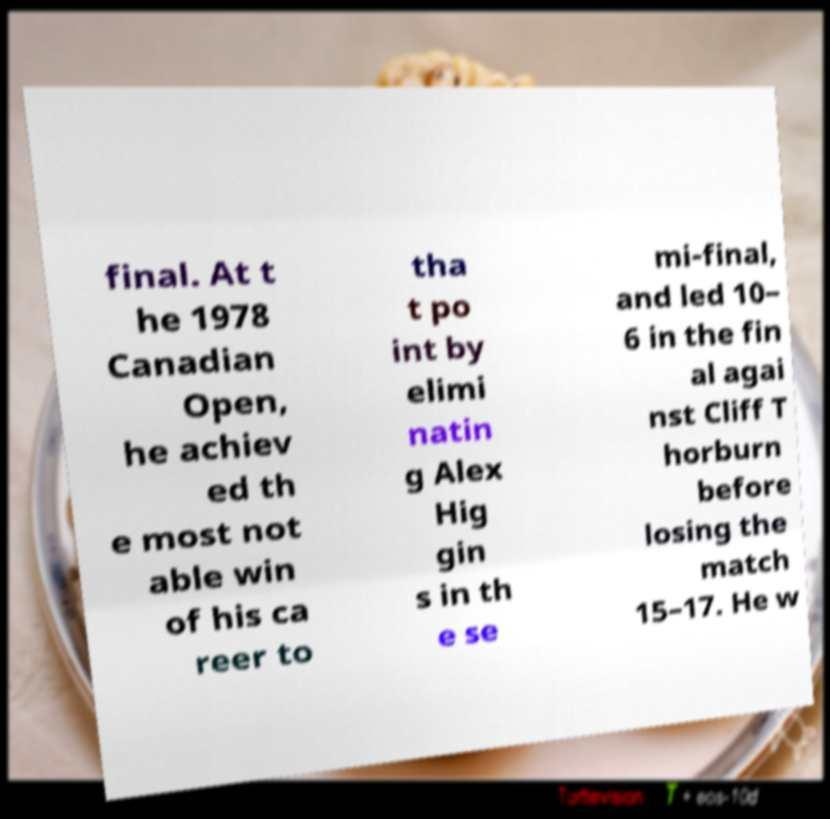There's text embedded in this image that I need extracted. Can you transcribe it verbatim? final. At t he 1978 Canadian Open, he achiev ed th e most not able win of his ca reer to tha t po int by elimi natin g Alex Hig gin s in th e se mi-final, and led 10– 6 in the fin al agai nst Cliff T horburn before losing the match 15–17. He w 